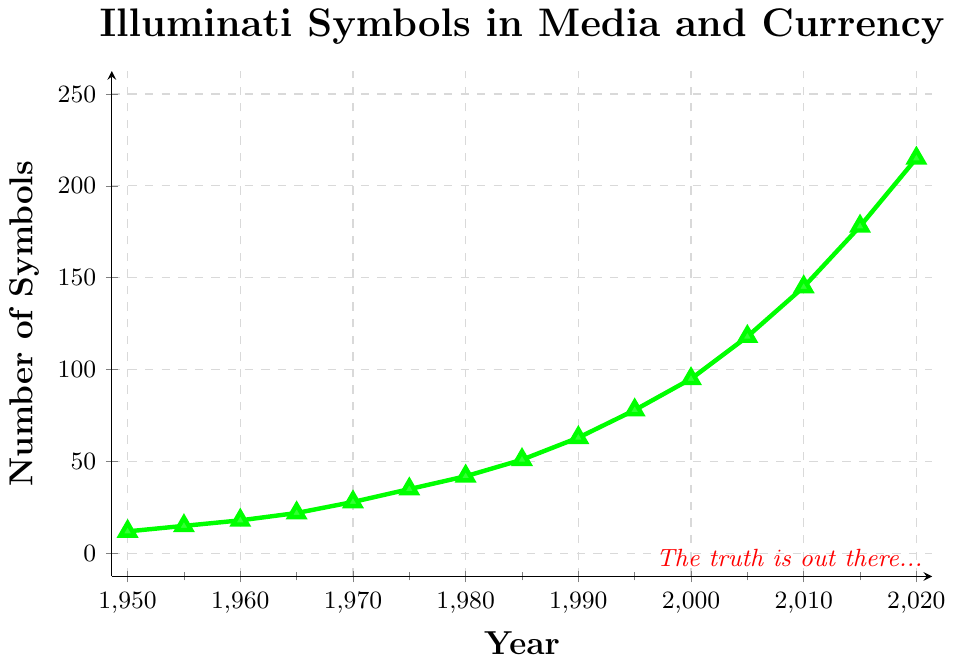What is the overall trend in the number of Illuminati-related symbols from 1950 to 2020? From the figure, the number of Illuminati-related symbols consistently increases over time. This is apparent as the line chart moves upward from 1950 (12 symbols) to 2020 (215 symbols).
Answer: Increasing Between which years did the number of Illuminati-related symbols see the most significant increase? The most significant increase can be observed between 2015 and 2020, where the count went from 178 to 215. This is a rise of 37 symbols. This is determined by carefully reviewing the changes in the data points alongside the timeline.
Answer: 2015-2020 Calculate the average increase per decade in the number of Illuminati-related symbols. To find the average increase per decade, first note the number of symbols in each decade: 1950 (12), 1960 (18), 1970 (28), 1980 (42), 1990 (63), 2000 (95), 2010 (145), 2020 (215). The changes per decade are 6, 10, 14, 21, 32, 50, 70. Summing these gives 203. Dividing by 7 gives an average of approximately 29 symbols per decade.
Answer: 29 symbols per decade In which year did the number of Illuminati-related symbols surpass 100 for the first time? By examining the figure, the data point surpassing 100 symbols can be found in the year 2005, where the count is 118 symbols.
Answer: 2005 How does the increase in the number of symbols from 1950 to 1980 compare to the increase from 1980 to 2010? From 1950 to 1980, the number of symbols increased from 12 to 42, a change of 30 symbols. From 1980 to 2010, the increase was from 42 to 145, which is a change of 103 symbols. By comparing these changes, 103 is much greater than 30.
Answer: The increase from 1980 to 2010 is much greater What is the percentage increase in the number of Illuminati-related symbols from 2000 to 2010? First, note the values in 2000 (95 symbols) and 2010 (145 symbols). The increase is 145 - 95 = 50 symbols. To find the percentage increase: (50 / 95) * 100% ≈ 52.63%.
Answer: 52.63% Identify any potential outliers or anomalies in the data. By reviewing the line chart, there are no abrupt spikes or drops; the data shows a consistent upward trend without any significant irregularities.
Answer: No apparent outliers Between 1990 and 2005, how many symbols were added to the count of Illuminati-related symbols? The counts are 63 in 1990 and 118 in 2005. The addition over this period is 118 - 63 = 55 symbols.
Answer: 55 symbols What is the visual trend displayed by the color and markers on the plot? The green color and triangle markers visually emphasize the consistent upward trend and growth in the number of symbols over time. This attracts attention to the progressive increase highlighted throughout the years.
Answer: Consistent upward trend with emphasis on increase 